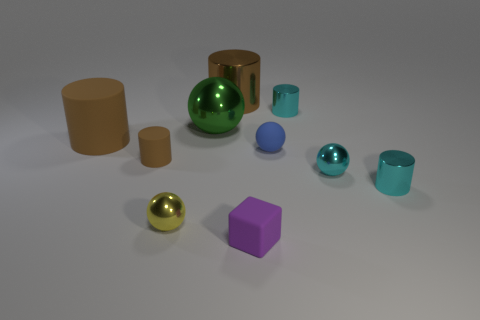Subtract all large spheres. How many spheres are left? 3 Subtract all green balls. How many cyan cylinders are left? 2 Subtract all yellow spheres. How many spheres are left? 3 Subtract 3 cylinders. How many cylinders are left? 2 Subtract all tiny cyan balls. Subtract all tiny purple blocks. How many objects are left? 8 Add 4 matte blocks. How many matte blocks are left? 5 Add 1 cylinders. How many cylinders exist? 6 Subtract 1 purple cubes. How many objects are left? 9 Subtract all cubes. How many objects are left? 9 Subtract all blue blocks. Subtract all cyan spheres. How many blocks are left? 1 